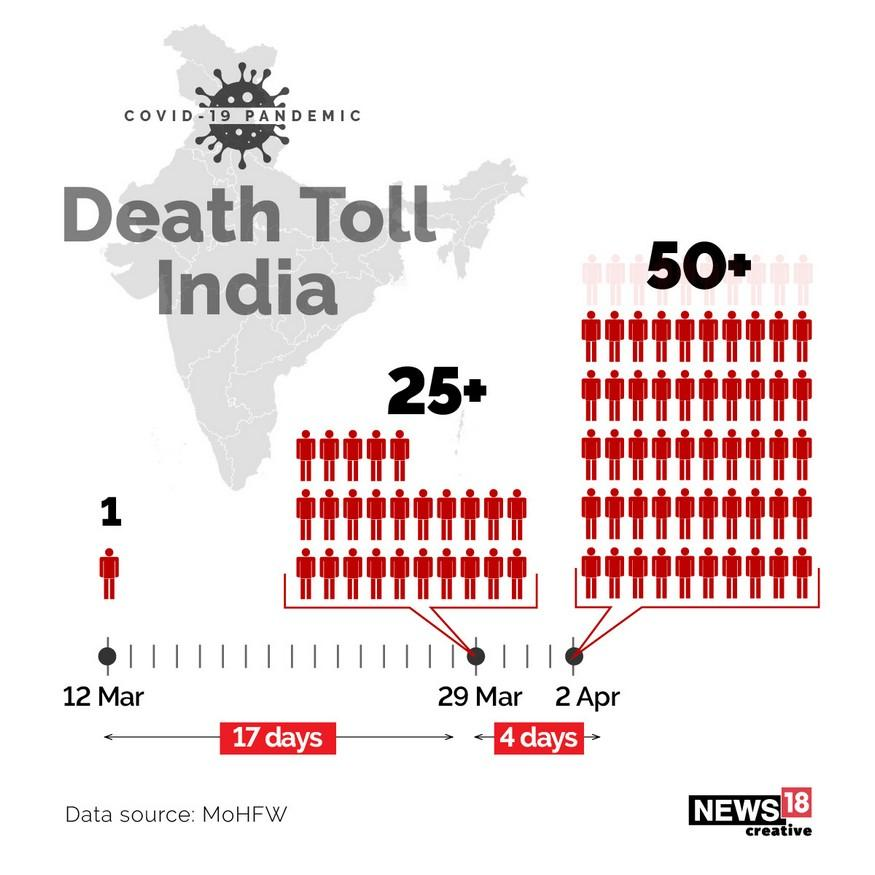Identify some key points in this picture. There are 4 days between April 2nd and March 29th. The 29th of March is different from the 12th of March by 17 days. On March 29th, there were 25 deaths. On April 2nd, there were at least 50 deaths. 